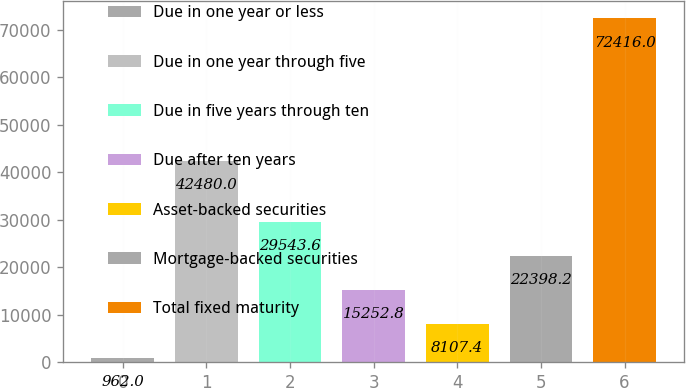Convert chart. <chart><loc_0><loc_0><loc_500><loc_500><bar_chart><fcel>Due in one year or less<fcel>Due in one year through five<fcel>Due in five years through ten<fcel>Due after ten years<fcel>Asset-backed securities<fcel>Mortgage-backed securities<fcel>Total fixed maturity<nl><fcel>962<fcel>42480<fcel>29543.6<fcel>15252.8<fcel>8107.4<fcel>22398.2<fcel>72416<nl></chart> 